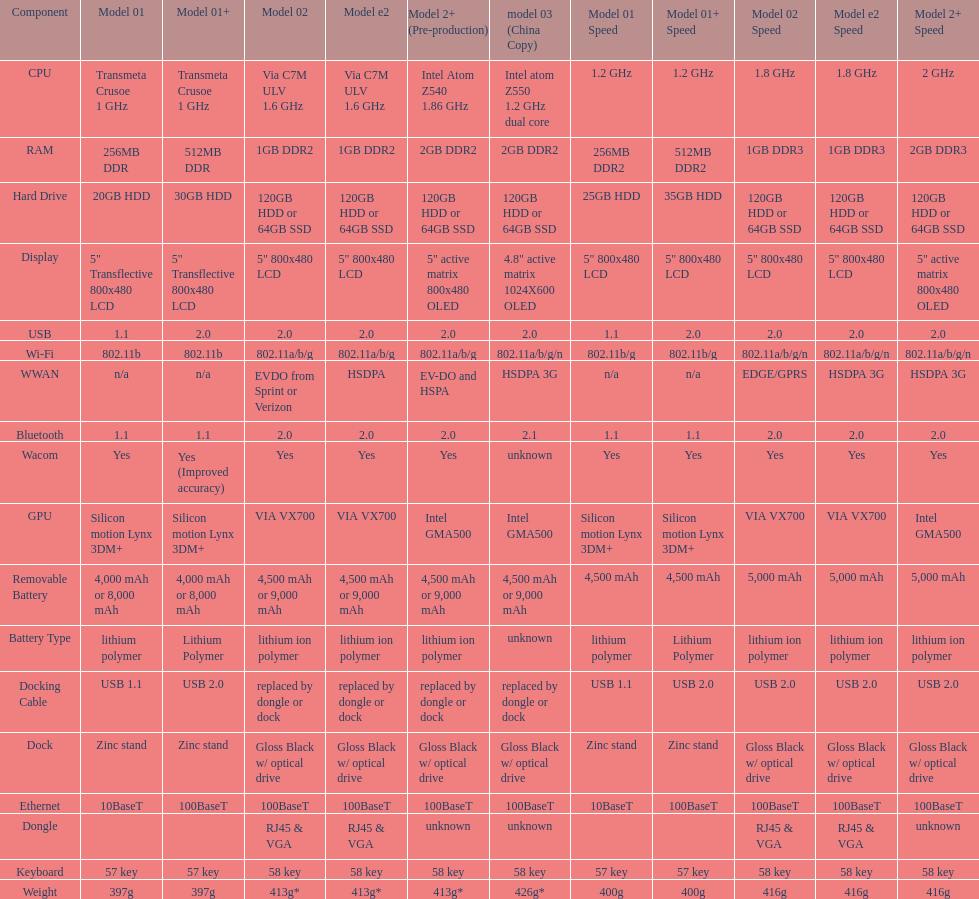What is the average number of models that have usb 2.0? 5. 